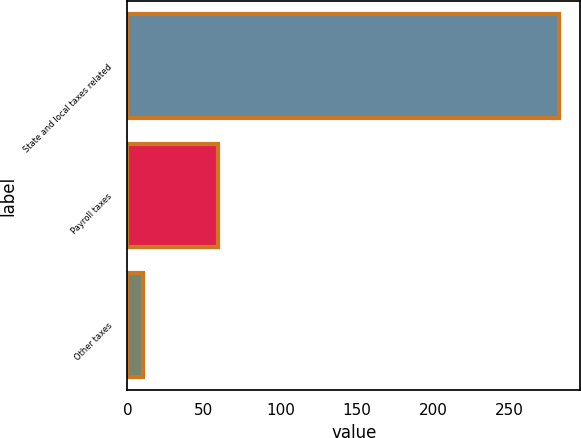Convert chart to OTSL. <chart><loc_0><loc_0><loc_500><loc_500><bar_chart><fcel>State and local taxes related<fcel>Payroll taxes<fcel>Other taxes<nl><fcel>282<fcel>59<fcel>10<nl></chart> 